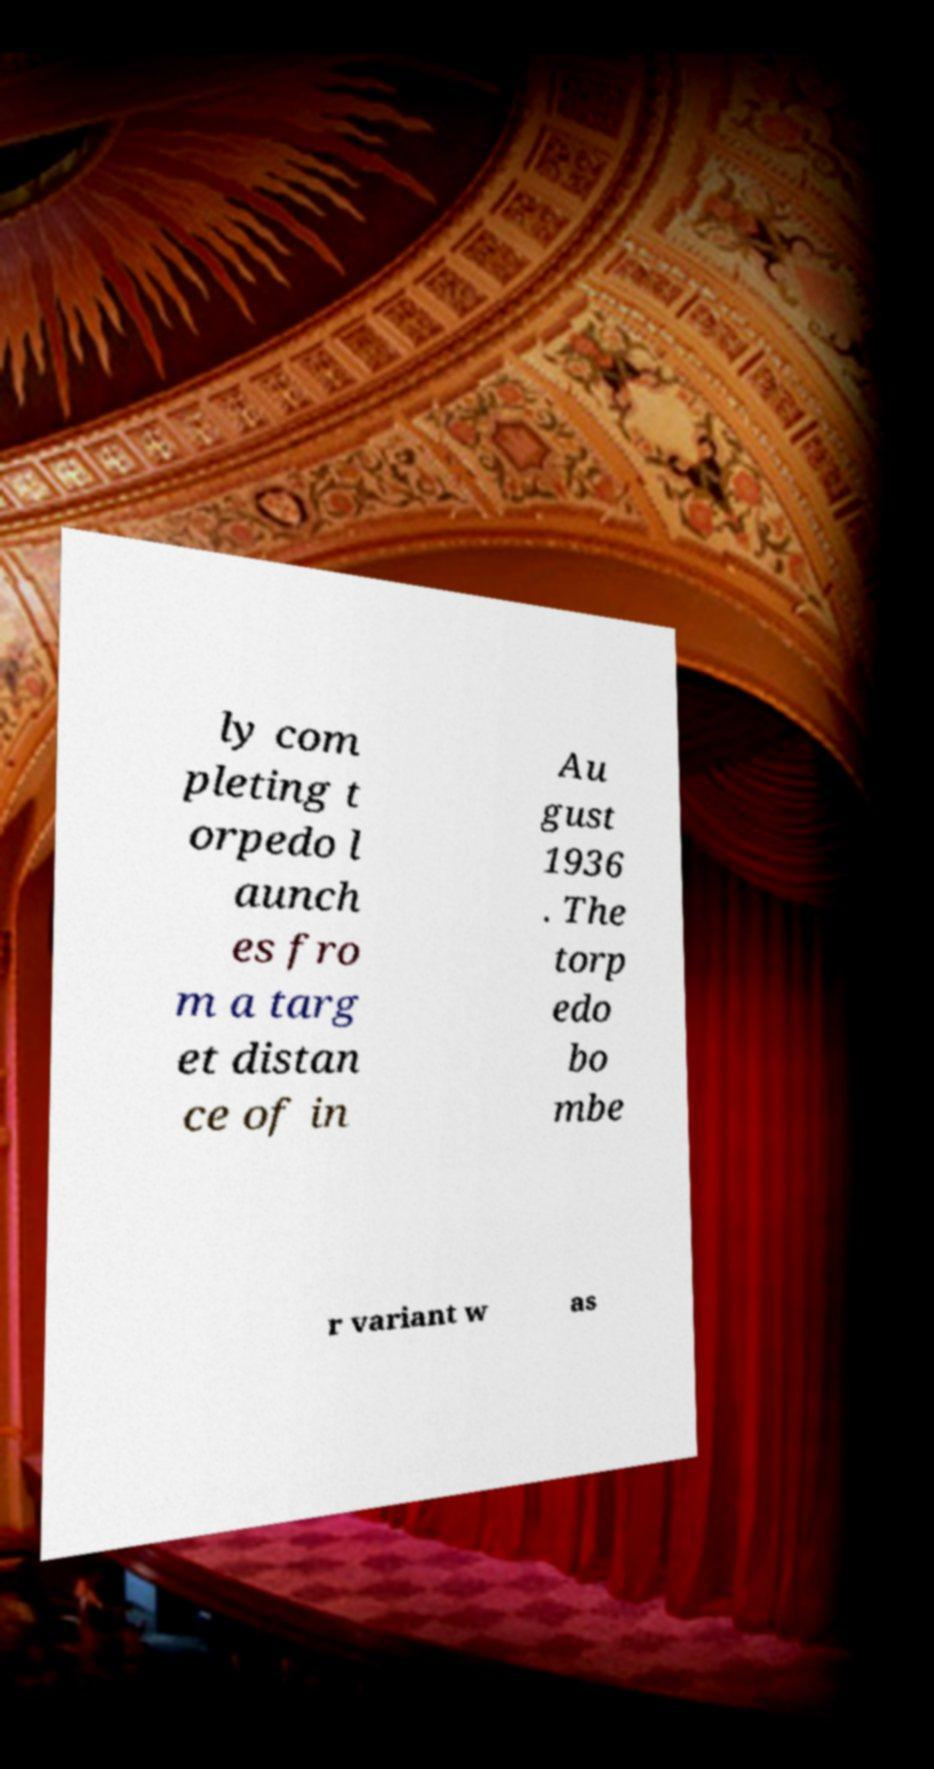I need the written content from this picture converted into text. Can you do that? ly com pleting t orpedo l aunch es fro m a targ et distan ce of in Au gust 1936 . The torp edo bo mbe r variant w as 